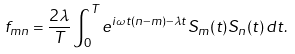<formula> <loc_0><loc_0><loc_500><loc_500>f _ { m n } = \frac { 2 \lambda } { T } \int _ { 0 } ^ { T } e ^ { i \omega t ( n - m ) - \lambda t } S _ { m } ( t ) S _ { n } ( t ) \, d t .</formula> 